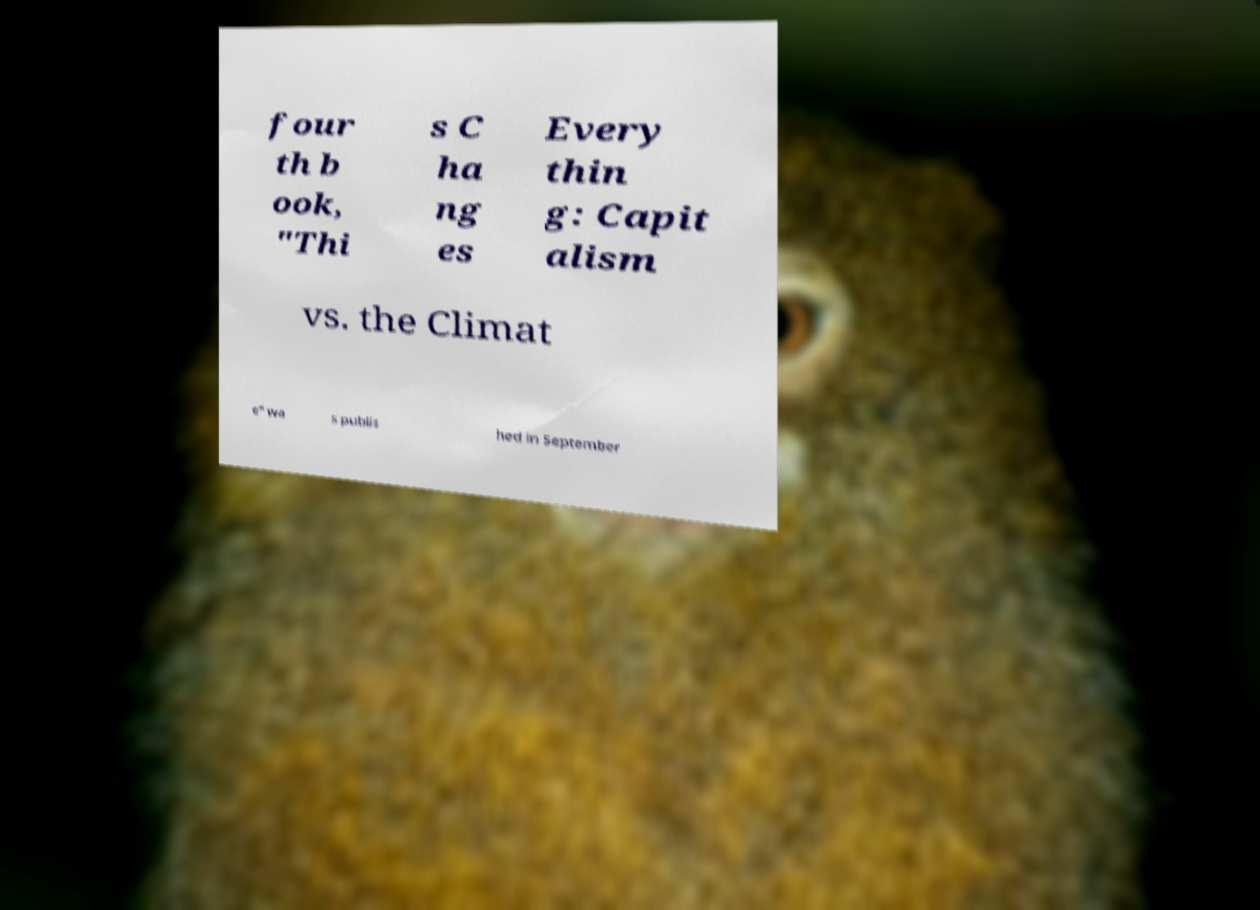Can you read and provide the text displayed in the image?This photo seems to have some interesting text. Can you extract and type it out for me? four th b ook, "Thi s C ha ng es Every thin g: Capit alism vs. the Climat e" wa s publis hed in September 